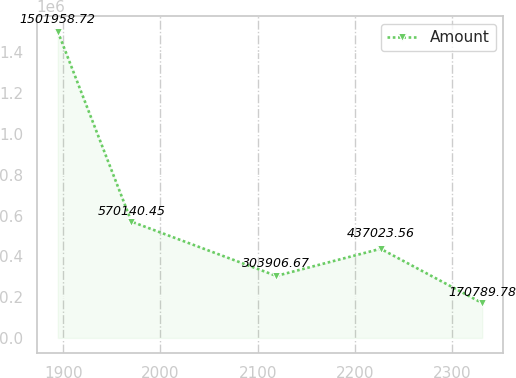<chart> <loc_0><loc_0><loc_500><loc_500><line_chart><ecel><fcel>Amount<nl><fcel>1894.36<fcel>1.50196e+06<nl><fcel>1970.12<fcel>570140<nl><fcel>2119.13<fcel>303907<nl><fcel>2226.41<fcel>437024<nl><fcel>2330.88<fcel>170790<nl></chart> 